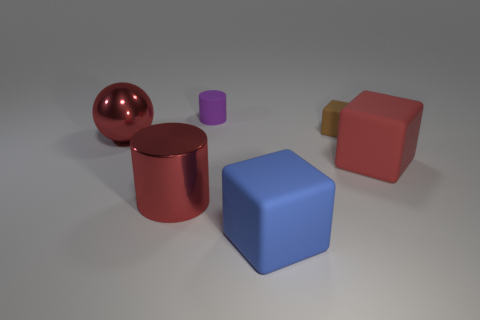Are there any tiny purple objects behind the purple matte object?
Your answer should be very brief. No. How many other big red spheres are made of the same material as the large red sphere?
Provide a succinct answer. 0. How many objects are either purple rubber cylinders or big cubes?
Your answer should be compact. 3. Are any big shiny cylinders visible?
Ensure brevity in your answer.  Yes. There is a object in front of the big red cylinder to the left of the matte cube behind the large shiny ball; what is it made of?
Provide a short and direct response. Rubber. Is the number of blue blocks to the right of the red metal cylinder less than the number of large purple cylinders?
Your response must be concise. No. What material is the block that is the same size as the purple rubber object?
Give a very brief answer. Rubber. What size is the thing that is both left of the large blue object and on the right side of the metallic cylinder?
Offer a terse response. Small. There is a blue rubber thing that is the same shape as the brown rubber object; what is its size?
Offer a very short reply. Large. How many objects are either rubber cubes or blocks behind the blue matte block?
Give a very brief answer. 3. 